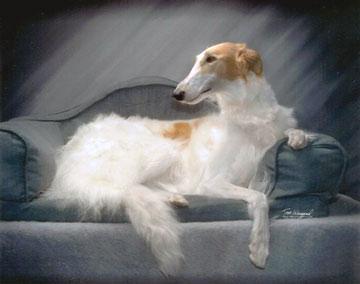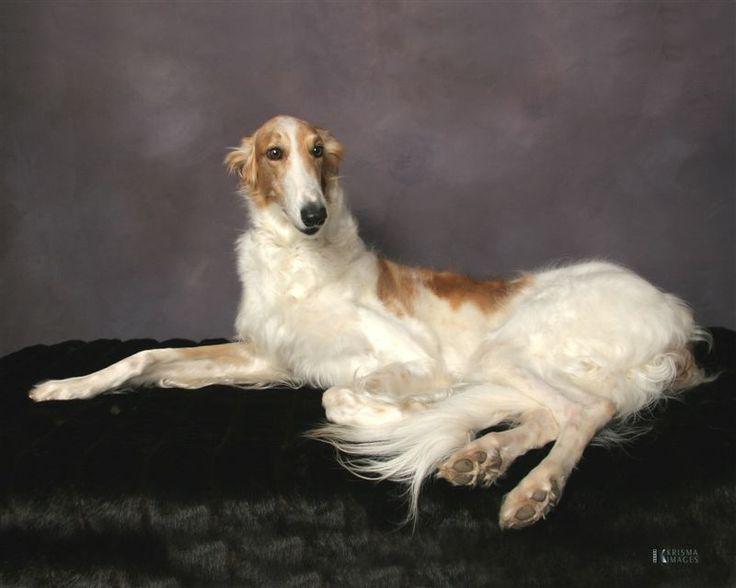The first image is the image on the left, the second image is the image on the right. Given the left and right images, does the statement "One dog is standing on all fours, and at least one dog has its head raised distinctly upward." hold true? Answer yes or no. No. The first image is the image on the left, the second image is the image on the right. For the images shown, is this caption "There are two dogs in the image pair, both facing right." true? Answer yes or no. No. The first image is the image on the left, the second image is the image on the right. Examine the images to the left and right. Is the description "Each image contains exactly one long-haired hound standing outdoors on all fours." accurate? Answer yes or no. No. The first image is the image on the left, the second image is the image on the right. Given the left and right images, does the statement "The dog in the left image is facing towards the left." hold true? Answer yes or no. Yes. 